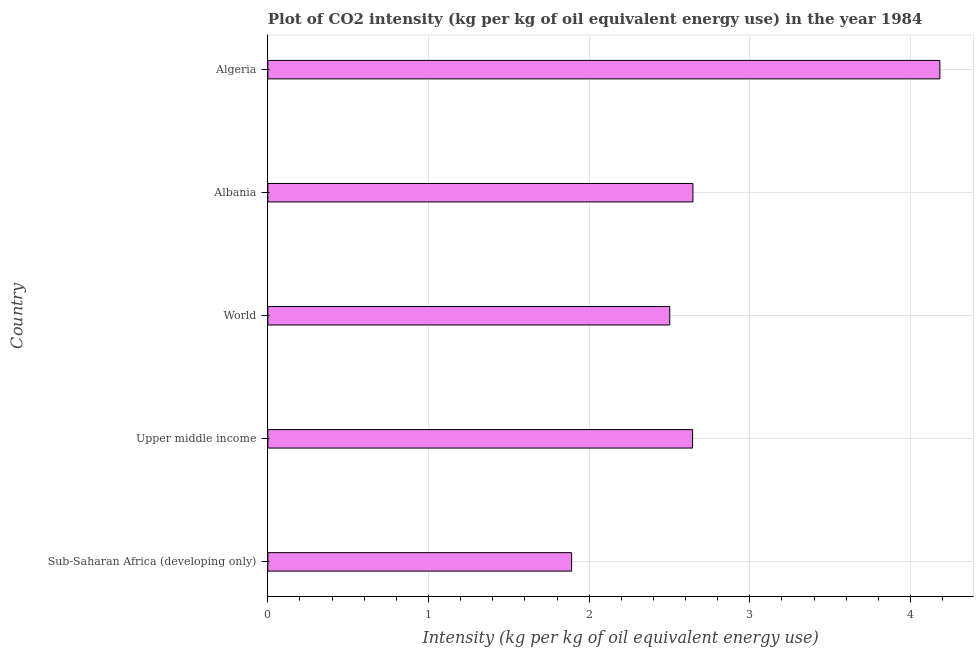Does the graph contain any zero values?
Ensure brevity in your answer.  No. Does the graph contain grids?
Ensure brevity in your answer.  Yes. What is the title of the graph?
Offer a very short reply. Plot of CO2 intensity (kg per kg of oil equivalent energy use) in the year 1984. What is the label or title of the X-axis?
Ensure brevity in your answer.  Intensity (kg per kg of oil equivalent energy use). What is the label or title of the Y-axis?
Give a very brief answer. Country. What is the co2 intensity in Albania?
Offer a very short reply. 2.65. Across all countries, what is the maximum co2 intensity?
Offer a terse response. 4.18. Across all countries, what is the minimum co2 intensity?
Offer a terse response. 1.89. In which country was the co2 intensity maximum?
Offer a very short reply. Algeria. In which country was the co2 intensity minimum?
Provide a succinct answer. Sub-Saharan Africa (developing only). What is the sum of the co2 intensity?
Provide a succinct answer. 13.87. What is the difference between the co2 intensity in Algeria and Sub-Saharan Africa (developing only)?
Your response must be concise. 2.29. What is the average co2 intensity per country?
Give a very brief answer. 2.77. What is the median co2 intensity?
Give a very brief answer. 2.64. What is the ratio of the co2 intensity in Algeria to that in Upper middle income?
Provide a short and direct response. 1.58. What is the difference between the highest and the second highest co2 intensity?
Your response must be concise. 1.54. What is the difference between the highest and the lowest co2 intensity?
Offer a terse response. 2.29. In how many countries, is the co2 intensity greater than the average co2 intensity taken over all countries?
Offer a very short reply. 1. Are all the bars in the graph horizontal?
Give a very brief answer. Yes. How many countries are there in the graph?
Ensure brevity in your answer.  5. What is the difference between two consecutive major ticks on the X-axis?
Offer a terse response. 1. What is the Intensity (kg per kg of oil equivalent energy use) of Sub-Saharan Africa (developing only)?
Offer a terse response. 1.89. What is the Intensity (kg per kg of oil equivalent energy use) in Upper middle income?
Offer a terse response. 2.64. What is the Intensity (kg per kg of oil equivalent energy use) of World?
Provide a short and direct response. 2.5. What is the Intensity (kg per kg of oil equivalent energy use) of Albania?
Give a very brief answer. 2.65. What is the Intensity (kg per kg of oil equivalent energy use) of Algeria?
Ensure brevity in your answer.  4.18. What is the difference between the Intensity (kg per kg of oil equivalent energy use) in Sub-Saharan Africa (developing only) and Upper middle income?
Provide a succinct answer. -0.75. What is the difference between the Intensity (kg per kg of oil equivalent energy use) in Sub-Saharan Africa (developing only) and World?
Ensure brevity in your answer.  -0.61. What is the difference between the Intensity (kg per kg of oil equivalent energy use) in Sub-Saharan Africa (developing only) and Albania?
Make the answer very short. -0.76. What is the difference between the Intensity (kg per kg of oil equivalent energy use) in Sub-Saharan Africa (developing only) and Algeria?
Provide a succinct answer. -2.29. What is the difference between the Intensity (kg per kg of oil equivalent energy use) in Upper middle income and World?
Your response must be concise. 0.14. What is the difference between the Intensity (kg per kg of oil equivalent energy use) in Upper middle income and Albania?
Ensure brevity in your answer.  -0. What is the difference between the Intensity (kg per kg of oil equivalent energy use) in Upper middle income and Algeria?
Your answer should be compact. -1.54. What is the difference between the Intensity (kg per kg of oil equivalent energy use) in World and Albania?
Give a very brief answer. -0.14. What is the difference between the Intensity (kg per kg of oil equivalent energy use) in World and Algeria?
Your response must be concise. -1.68. What is the difference between the Intensity (kg per kg of oil equivalent energy use) in Albania and Algeria?
Keep it short and to the point. -1.54. What is the ratio of the Intensity (kg per kg of oil equivalent energy use) in Sub-Saharan Africa (developing only) to that in Upper middle income?
Provide a short and direct response. 0.71. What is the ratio of the Intensity (kg per kg of oil equivalent energy use) in Sub-Saharan Africa (developing only) to that in World?
Your answer should be compact. 0.76. What is the ratio of the Intensity (kg per kg of oil equivalent energy use) in Sub-Saharan Africa (developing only) to that in Albania?
Give a very brief answer. 0.71. What is the ratio of the Intensity (kg per kg of oil equivalent energy use) in Sub-Saharan Africa (developing only) to that in Algeria?
Give a very brief answer. 0.45. What is the ratio of the Intensity (kg per kg of oil equivalent energy use) in Upper middle income to that in World?
Make the answer very short. 1.06. What is the ratio of the Intensity (kg per kg of oil equivalent energy use) in Upper middle income to that in Algeria?
Your response must be concise. 0.63. What is the ratio of the Intensity (kg per kg of oil equivalent energy use) in World to that in Albania?
Keep it short and to the point. 0.94. What is the ratio of the Intensity (kg per kg of oil equivalent energy use) in World to that in Algeria?
Your answer should be compact. 0.6. What is the ratio of the Intensity (kg per kg of oil equivalent energy use) in Albania to that in Algeria?
Keep it short and to the point. 0.63. 